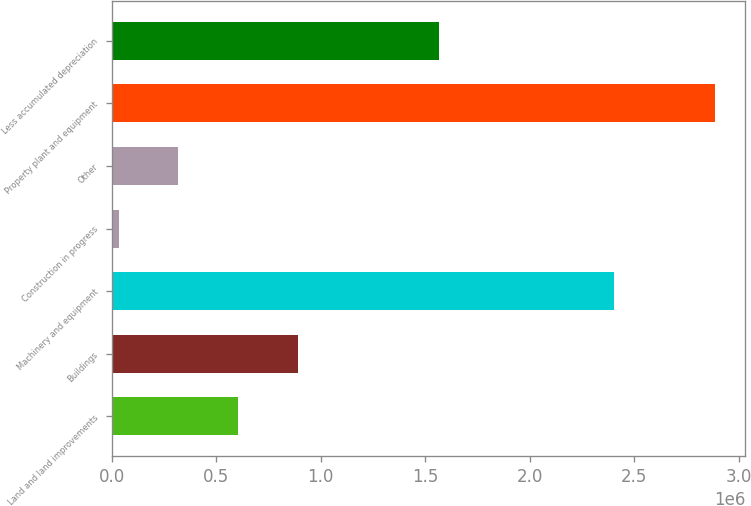Convert chart. <chart><loc_0><loc_0><loc_500><loc_500><bar_chart><fcel>Land and land improvements<fcel>Buildings<fcel>Machinery and equipment<fcel>Construction in progress<fcel>Other<fcel>Property plant and equipment<fcel>Less accumulated depreciation<nl><fcel>604218<fcel>889300<fcel>2.4014e+06<fcel>34054<fcel>319136<fcel>2.88487e+06<fcel>1.56436e+06<nl></chart> 